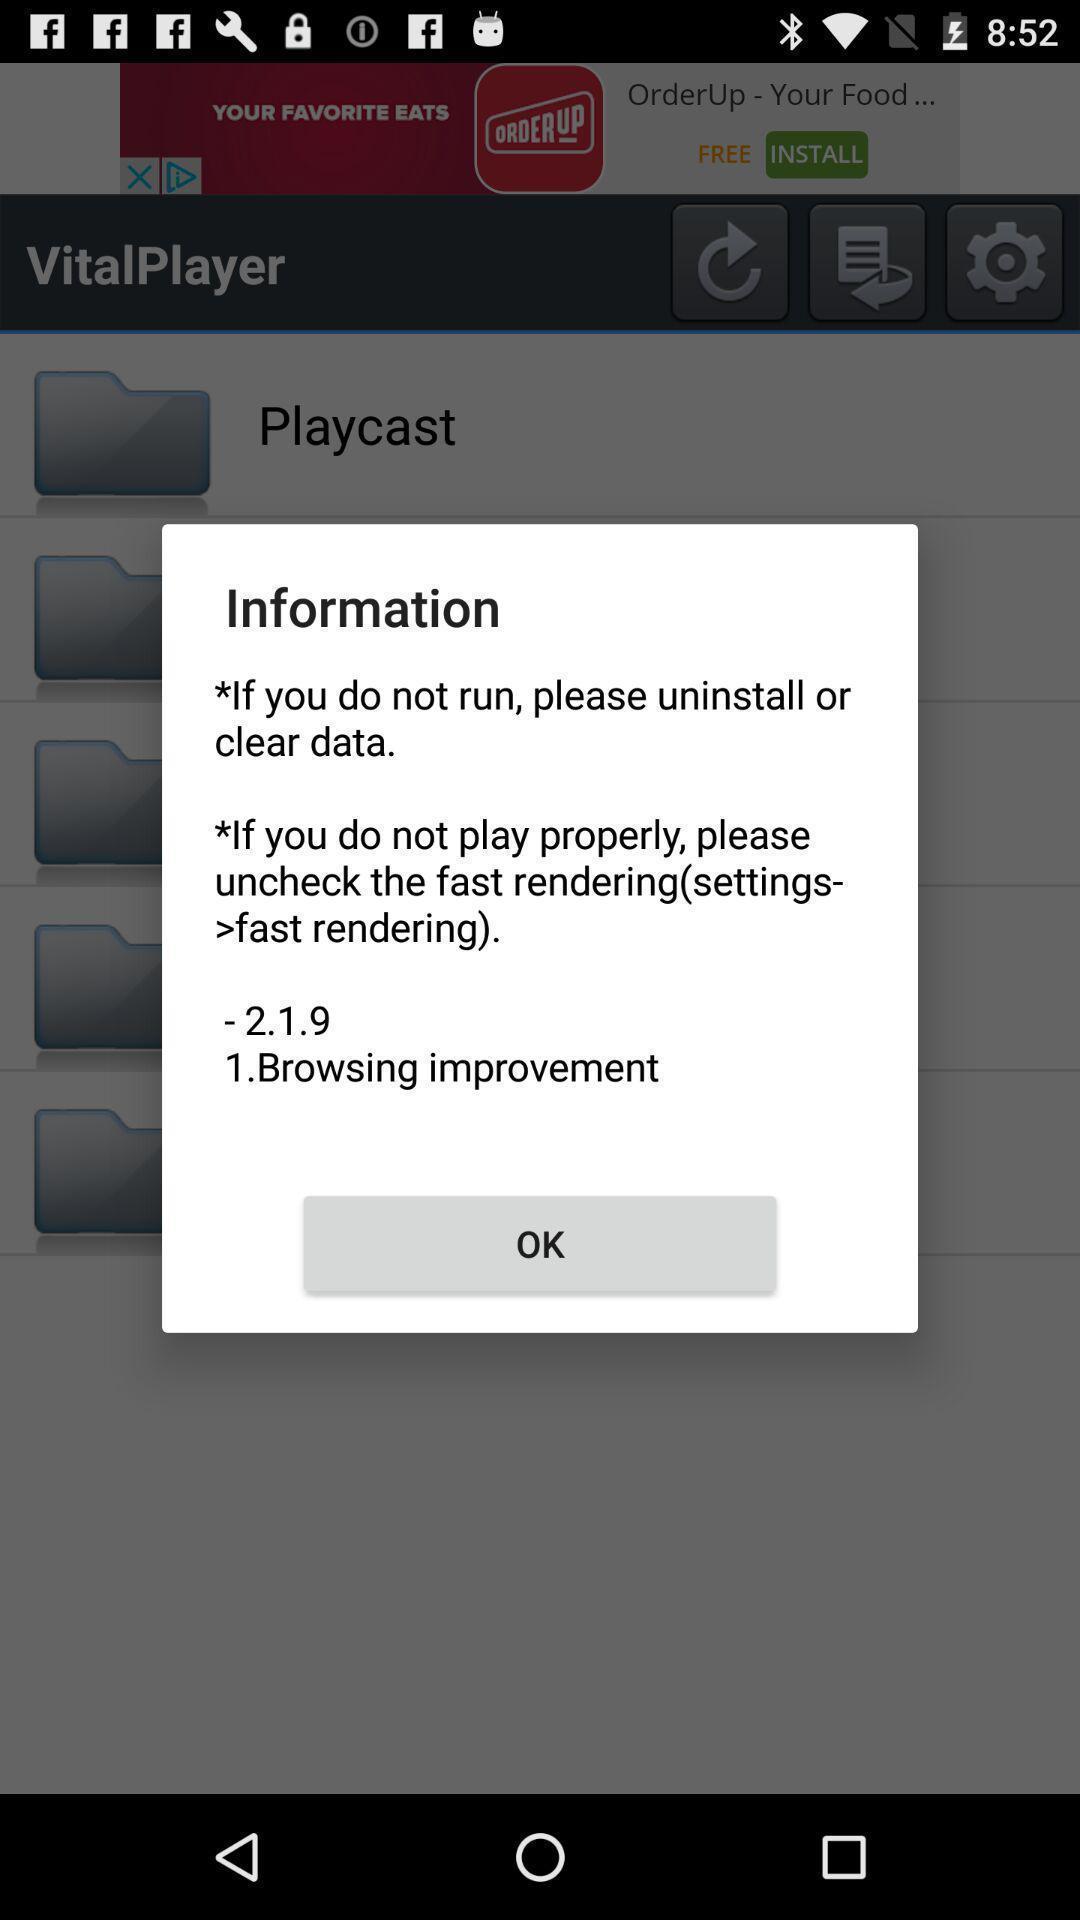Describe the content in this image. Pop-up showing instructions. 